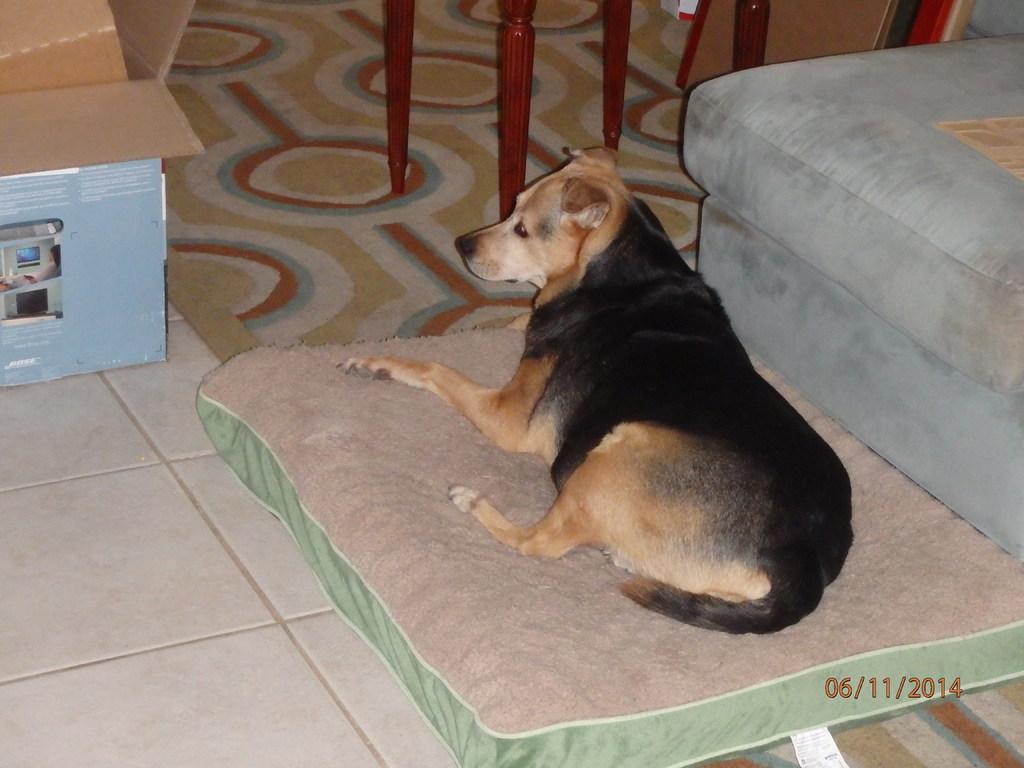In one or two sentences, can you explain what this image depicts? In the center of the image there is a dog on the bed. At the bottom of the image there is floor. There is carpet. To the right side of the image there is a sofa. To the left side of the image there is a box. 